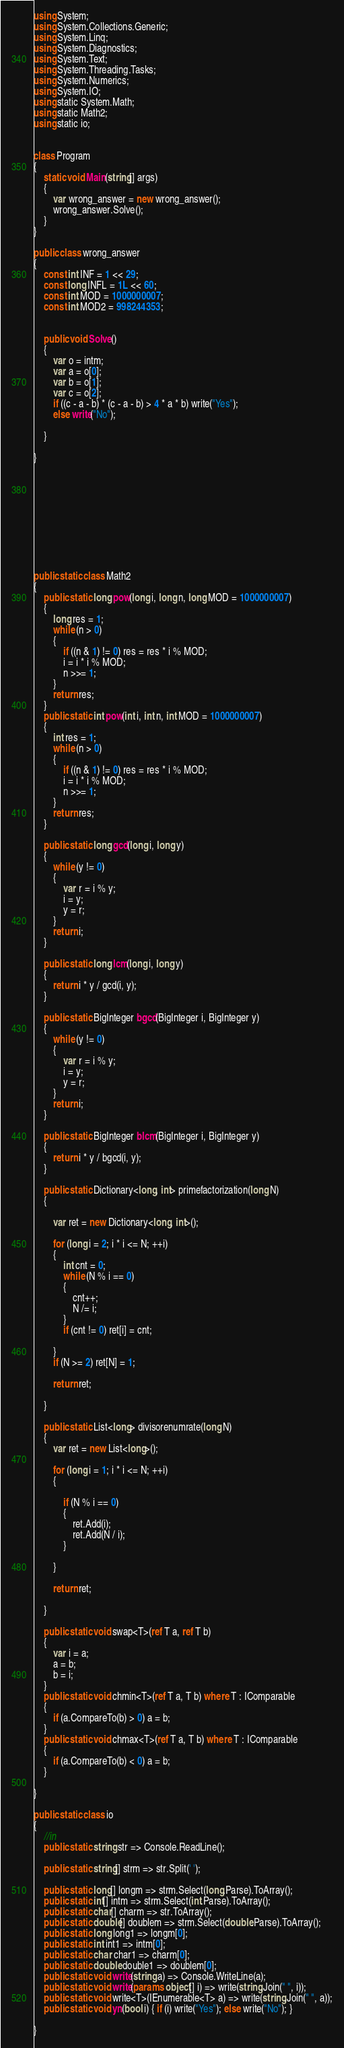<code> <loc_0><loc_0><loc_500><loc_500><_C#_>using System;
using System.Collections.Generic;
using System.Linq;
using System.Diagnostics;
using System.Text;
using System.Threading.Tasks;
using System.Numerics;
using System.IO;
using static System.Math;
using static Math2;
using static io;


class Program
{
    static void Main(string[] args)
    {
        var wrong_answer = new wrong_answer();
        wrong_answer.Solve();
    }
}

public class wrong_answer
{
    const int INF = 1 << 29;
    const long INFL = 1L << 60;
    const int MOD = 1000000007;
    const int MOD2 = 998244353;


    public void Solve()
    {
        var o = intm;
        var a = o[0];
        var b = o[1];
        var c = o[2];
        if ((c - a - b) * (c - a - b) > 4 * a * b) write("Yes");
        else write("No");

    }

}










public static class Math2
{
    public static long pow(long i, long n, long MOD = 1000000007)
    {
        long res = 1;
        while (n > 0)
        {
            if ((n & 1) != 0) res = res * i % MOD;
            i = i * i % MOD;
            n >>= 1;
        }
        return res;
    }
    public static int pow(int i, int n, int MOD = 1000000007)
    {
        int res = 1;
        while (n > 0)
        {
            if ((n & 1) != 0) res = res * i % MOD;
            i = i * i % MOD;
            n >>= 1;
        }
        return res;
    }

    public static long gcd(long i, long y)
    {
        while (y != 0)
        {
            var r = i % y;
            i = y;
            y = r;
        }
        return i;
    }

    public static long lcm(long i, long y)
    {
        return i * y / gcd(i, y);
    }

    public static BigInteger bgcd(BigInteger i, BigInteger y)
    {
        while (y != 0)
        {
            var r = i % y;
            i = y;
            y = r;
        }
        return i;
    }

    public static BigInteger blcm(BigInteger i, BigInteger y)
    {
        return i * y / bgcd(i, y);
    }

    public static Dictionary<long, int> primefactorization(long N)
    {

        var ret = new Dictionary<long, int>();

        for (long i = 2; i * i <= N; ++i)
        {
            int cnt = 0;
            while (N % i == 0)
            {
                cnt++;
                N /= i;
            }
            if (cnt != 0) ret[i] = cnt;

        }
        if (N >= 2) ret[N] = 1;

        return ret;

    }

    public static List<long> divisorenumrate(long N)
    {
        var ret = new List<long>();

        for (long i = 1; i * i <= N; ++i)
        {

            if (N % i == 0)
            {
                ret.Add(i);
                ret.Add(N / i);
            }

        }

        return ret;

    }

    public static void swap<T>(ref T a, ref T b)
    {
        var i = a;
        a = b;
        b = i;
    }
    public static void chmin<T>(ref T a, T b) where T : IComparable
    {
        if (a.CompareTo(b) > 0) a = b;
    }
    public static void chmax<T>(ref T a, T b) where T : IComparable
    {
        if (a.CompareTo(b) < 0) a = b;
    }

}

public static class io
{
    //in
    public static string str => Console.ReadLine();

    public static string[] strm => str.Split(' ');

    public static long[] longm => strm.Select(long.Parse).ToArray();
    public static int[] intm => strm.Select(int.Parse).ToArray();
    public static char[] charm => str.ToArray();
    public static double[] doublem => strm.Select(double.Parse).ToArray();
    public static long long1 => longm[0];
    public static int int1 => intm[0];
    public static char char1 => charm[0];
    public static double double1 => doublem[0];
    public static void write(string a) => Console.WriteLine(a);
    public static void write(params object[] i) => write(string.Join(" ", i));
    public static void write<T>(IEnumerable<T> a) => write(string.Join(" ", a));
    public static void yn(bool i) { if (i) write("Yes"); else write("No"); }

}
</code> 